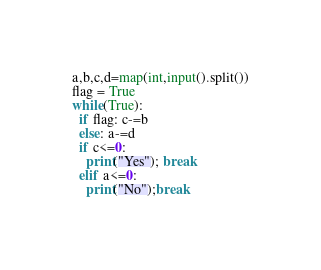Convert code to text. <code><loc_0><loc_0><loc_500><loc_500><_Cython_>a,b,c,d=map(int,input().split())
flag = True
while(True):
  if flag: c-=b
  else: a-=d
  if c<=0:
    print("Yes"); break
  elif a<=0:
    print("No");break</code> 